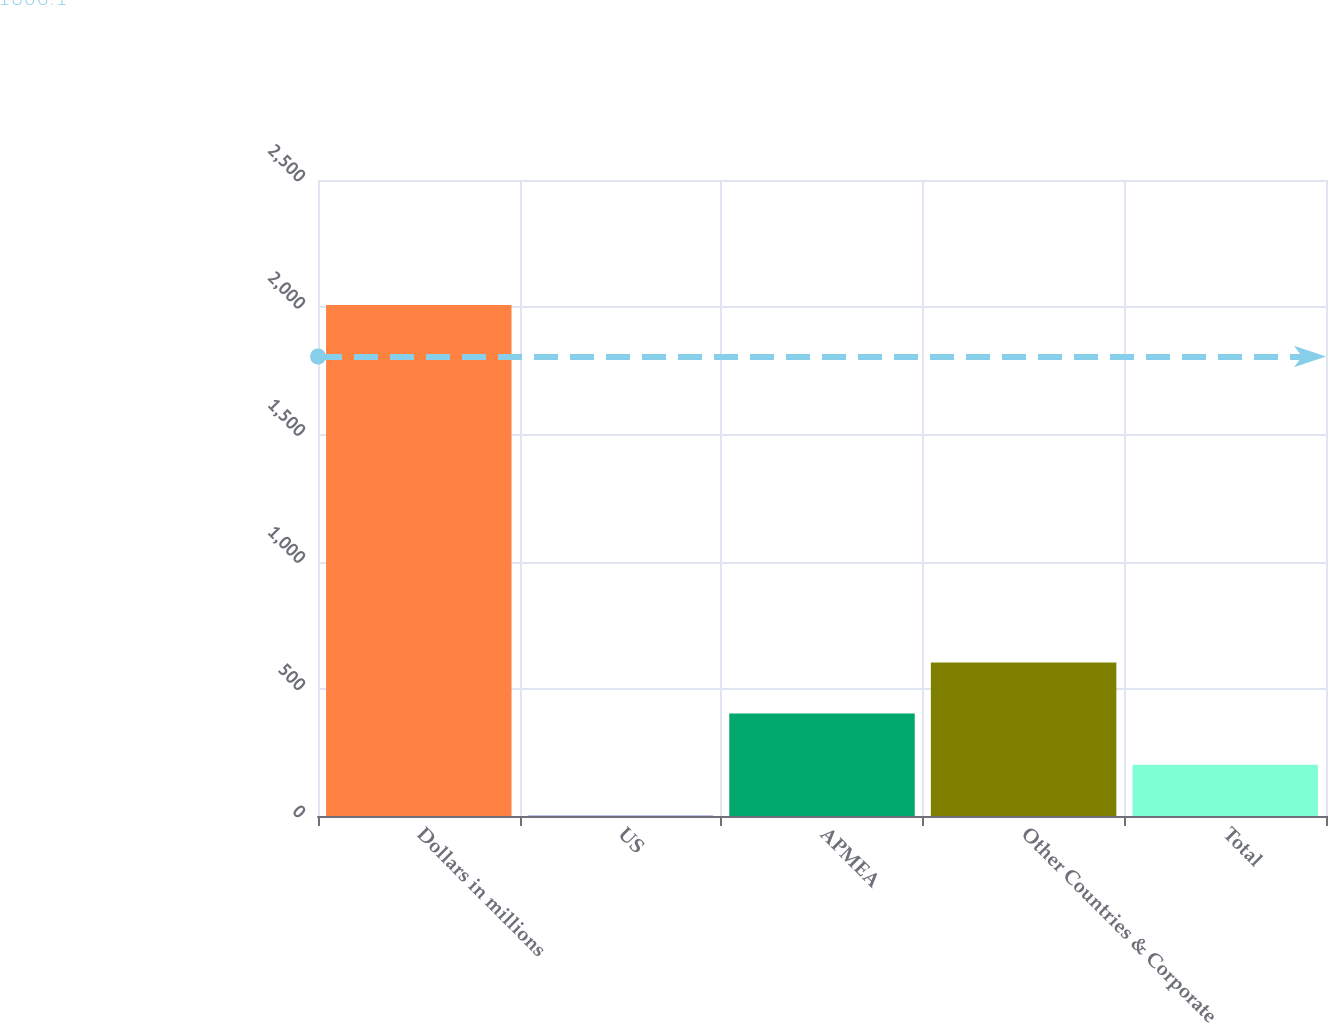<chart> <loc_0><loc_0><loc_500><loc_500><bar_chart><fcel>Dollars in millions<fcel>US<fcel>APMEA<fcel>Other Countries & Corporate<fcel>Total<nl><fcel>2009<fcel>1<fcel>402.6<fcel>603.4<fcel>201.8<nl></chart> 